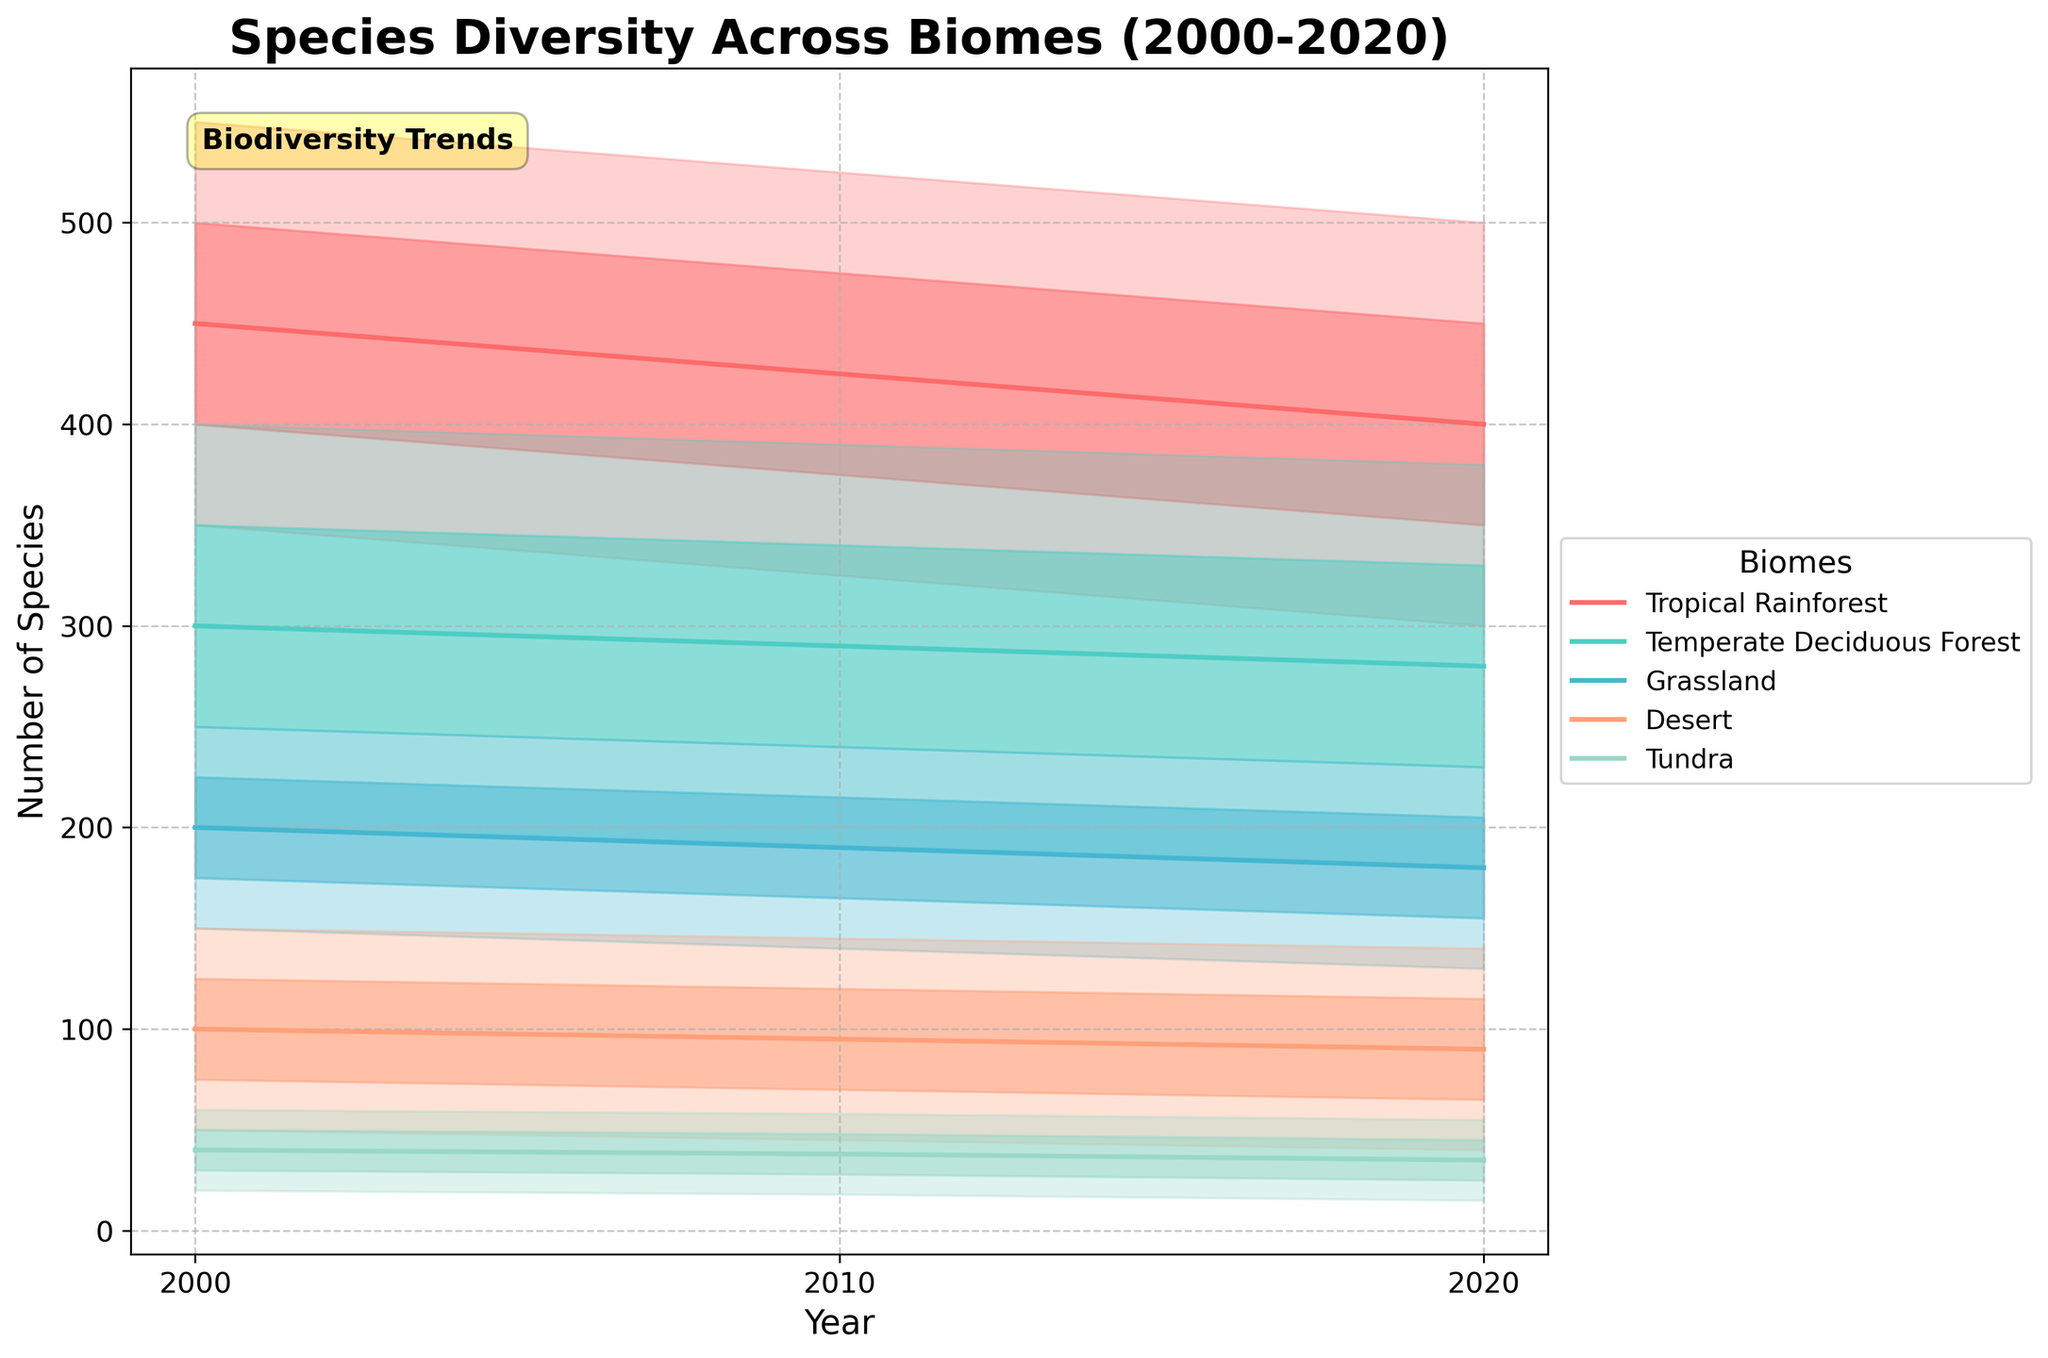What's the title of the plot? The title of the plot is written at the top of the plot. It states, "Species Diversity Across Biomes (2000-2020)."
Answer: Species Diversity Across Biomes (2000-2020) What are the axes labels of the plot? The x-axis is labeled as "Year" and the y-axis is labeled as "Number of Species." These labels are indicated on the bottom and side of the plot, respectively.
Answer: Year, Number of Species What color is used to represent the Tropical Rainforest biome? The color representing the Tropical Rainforest biome can be identified by looking at the legend on the right side of the plot. The Tropical Rainforest is represented by a red shade.
Answer: Red Which biome has the highest median species count in 2020? To answer this, look at the median lines (solid lines) in 2020. Among all lines, the Tropical Rainforest median line is the highest.
Answer: Tropical Rainforest What's the range of species count for Temperate Deciduous Forest in 2000? The range is determined by subtracting the low value from the high value. For this biome in 2000, the low value is 200 and the high value is 400. Thus, the range is 400 - 200.
Answer: 200 How does the median species count in Grassland change from 2000 to 2020? To find the change, look at the median lines for Grassland in both 2000 and 2020. In 2000, the median species count is 200, and in 2020, it's 180. The change is 180 - 200.
Answer: -20 Which biome shows the least variability in species count over the given years? Variability can be inferred by comparing the spread between the lower and upper bounds (Low and High) of each biome. The Tundra, having the smallest spread, indicates the least variability.
Answer: Tundra Which biome had a higher species count median in 2010, Desert or Tundra? By comparing the median lines in 2010 for both biomes, the Desert line is at 95, while the Tundra line is at 38, making the Desert higher.
Answer: Desert What is the interquartile range (IQR) for Desert in 2020? The IQR is calculated by subtracting the Q1 value from the Q3 value. For the Desert in 2020, Q3 is 115 and Q1 is 65. Thus, the IQR is 115 - 65.
Answer: 50 